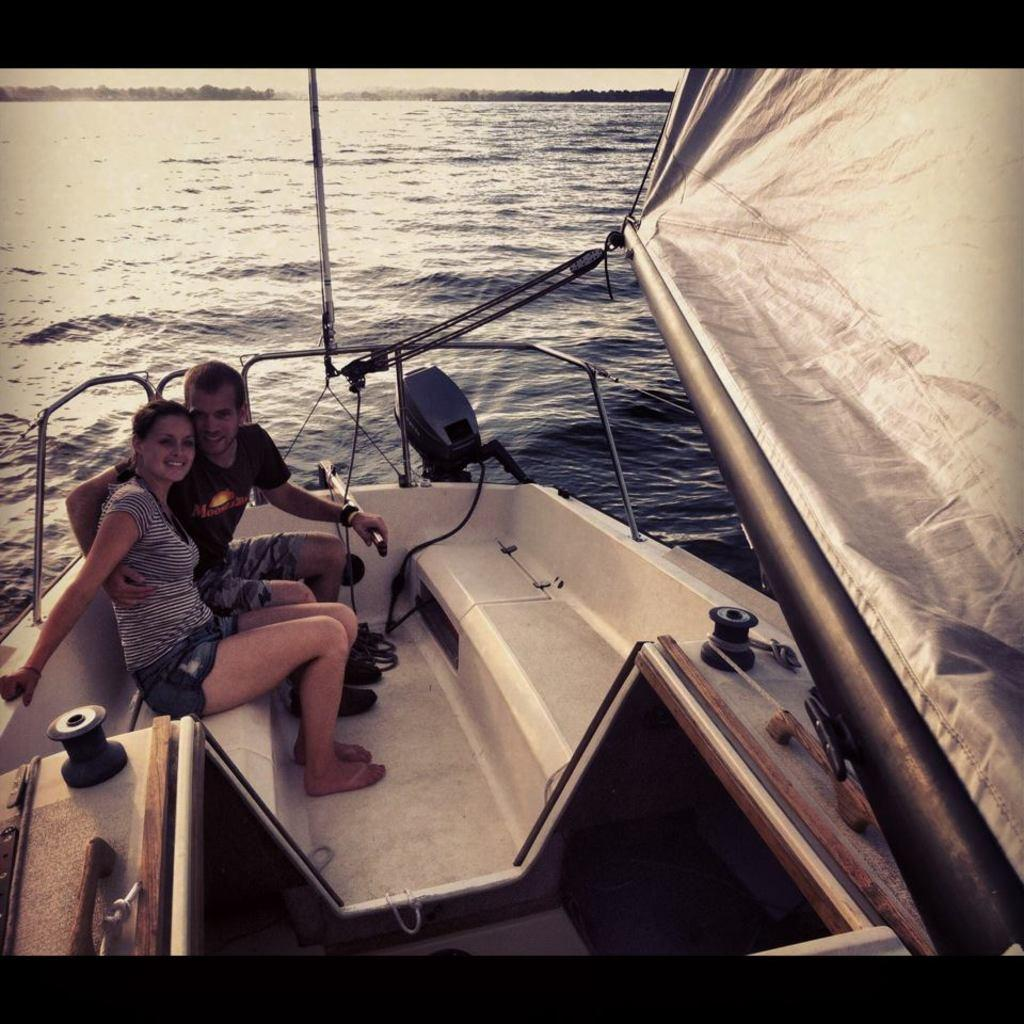Who is present in the image? There is a couple in the image. Where are the couple sitting? The couple is sitting in a ship. What body of water is the ship on? The ship is on a river. What can be seen in the background of the image? There are trees and the sky visible in the background of the image. How does the couple react to the sudden rainstorm in the image? There is no rainstorm present in the image; the sky is visible and appears clear. 